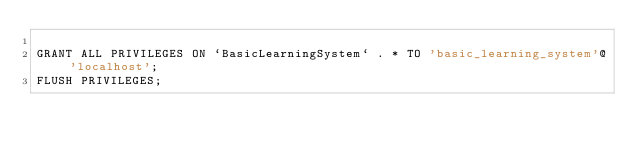<code> <loc_0><loc_0><loc_500><loc_500><_SQL_>
GRANT ALL PRIVILEGES ON `BasicLearningSystem` . * TO 'basic_learning_system'@'localhost';
FLUSH PRIVILEGES;</code> 